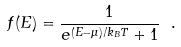Convert formula to latex. <formula><loc_0><loc_0><loc_500><loc_500>f ( E ) = \frac { 1 } { e ^ { ( E - \mu ) / k _ { B } T } + 1 } \ .</formula> 